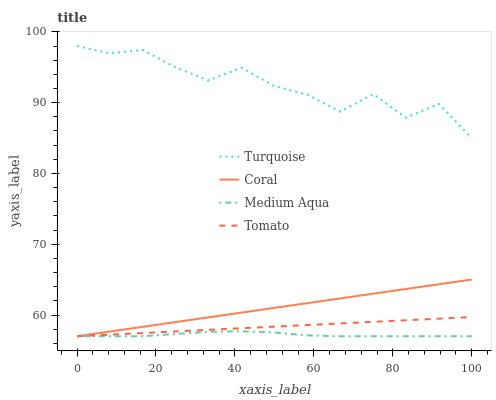Does Turquoise have the minimum area under the curve?
Answer yes or no. No. Does Medium Aqua have the maximum area under the curve?
Answer yes or no. No. Is Medium Aqua the smoothest?
Answer yes or no. No. Is Medium Aqua the roughest?
Answer yes or no. No. Does Turquoise have the lowest value?
Answer yes or no. No. Does Medium Aqua have the highest value?
Answer yes or no. No. Is Tomato less than Turquoise?
Answer yes or no. Yes. Is Turquoise greater than Tomato?
Answer yes or no. Yes. Does Tomato intersect Turquoise?
Answer yes or no. No. 